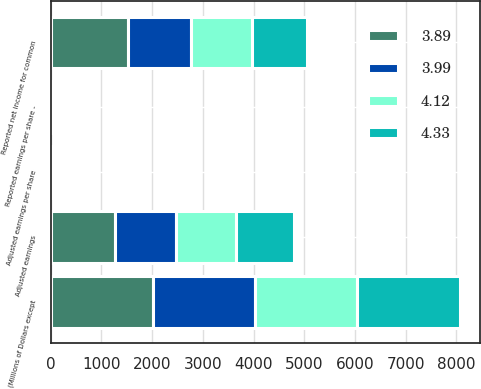Convert chart to OTSL. <chart><loc_0><loc_0><loc_500><loc_500><stacked_bar_chart><ecel><fcel>(Millions of Dollars except<fcel>Reported net income for common<fcel>Adjusted earnings<fcel>Reported earnings per share -<fcel>Adjusted earnings per share<nl><fcel>4.33<fcel>2014<fcel>1092<fcel>1140<fcel>3.73<fcel>3.89<nl><fcel>4.12<fcel>2015<fcel>1193<fcel>1196<fcel>4.07<fcel>4.08<nl><fcel>3.99<fcel>2016<fcel>1245<fcel>1198<fcel>4.15<fcel>3.99<nl><fcel>3.89<fcel>2017<fcel>1525<fcel>1264<fcel>4.97<fcel>4.12<nl></chart> 